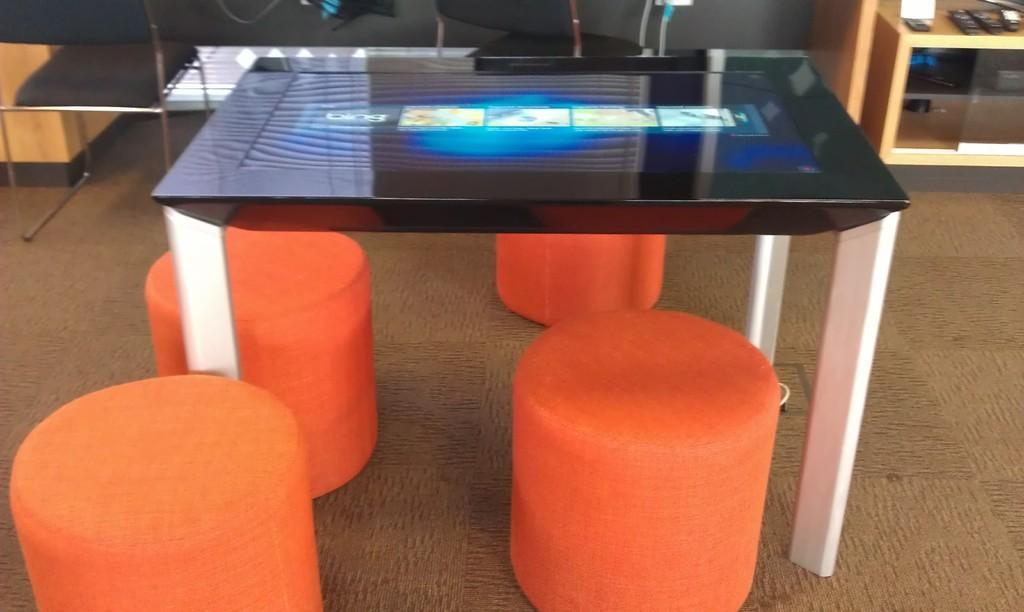In one or two sentences, can you explain what this image depicts? In this picture I can see a table with a screen, there are stools, remotes and some other objects. 